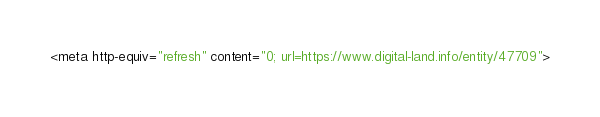<code> <loc_0><loc_0><loc_500><loc_500><_HTML_><meta http-equiv="refresh" content="0; url=https://www.digital-land.info/entity/47709"></code> 